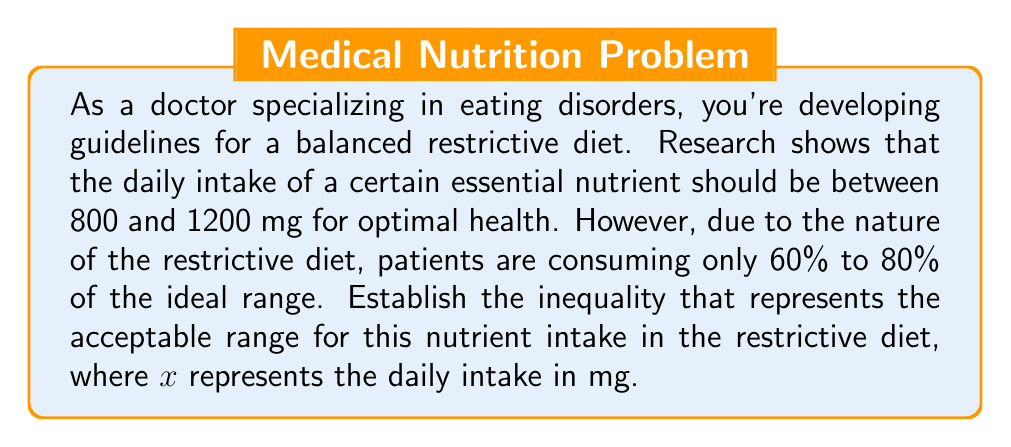Show me your answer to this math problem. Let's approach this step-by-step:

1) First, we need to establish the ideal range:
   Lower bound: 800 mg
   Upper bound: 1200 mg

2) Now, we need to consider that patients on the restrictive diet are consuming only 60% to 80% of this ideal range.

3) For the lower bound:
   60% of 800 = $0.6 \times 800 = 480$ mg
   80% of 800 = $0.8 \times 800 = 640$ mg

4) For the upper bound:
   60% of 1200 = $0.6 \times 1200 = 720$ mg
   80% of 1200 = $0.8 \times 1200 = 960$ mg

5) Therefore, the acceptable range for the nutrient intake in the restrictive diet is between 480 mg and 960 mg.

6) We can represent this as an inequality:

   $$480 \leq x \leq 960$$

   where $x$ represents the daily intake of the nutrient in mg.

This inequality ensures that the intake is at least 60% of the lower ideal bound (480 mg) and at most 80% of the upper ideal bound (960 mg).
Answer: $$480 \leq x \leq 960$$ 